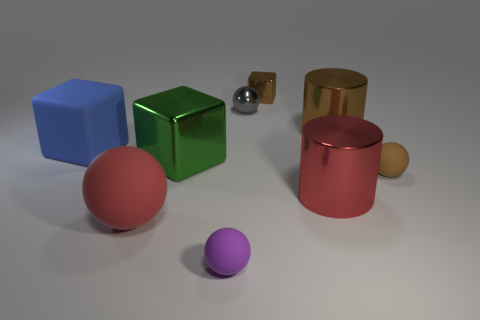What number of large red metallic objects are the same shape as the big brown metal object?
Offer a very short reply. 1. There is a big cylinder that is the same color as the large sphere; what is it made of?
Keep it short and to the point. Metal. Do the small brown thing that is behind the brown matte sphere and the red object that is behind the red sphere have the same material?
Your response must be concise. Yes. Are there more green metal objects on the left side of the brown matte object than small gray metallic spheres in front of the gray shiny thing?
Offer a very short reply. Yes. What material is the blue object that is the same shape as the big green object?
Your answer should be very brief. Rubber. There is a big matte object in front of the large blue block; is it the same color as the big cylinder that is in front of the rubber cube?
Provide a succinct answer. Yes. The small gray object has what shape?
Provide a short and direct response. Sphere. There is a big green thing that is behind the small purple matte ball; what is its shape?
Keep it short and to the point. Cube. Do the red cylinder to the right of the small purple rubber object and the blue object have the same material?
Your answer should be very brief. No. Are there the same number of brown rubber things that are on the left side of the purple rubber ball and big red shiny cylinders that are behind the big sphere?
Ensure brevity in your answer.  No. 